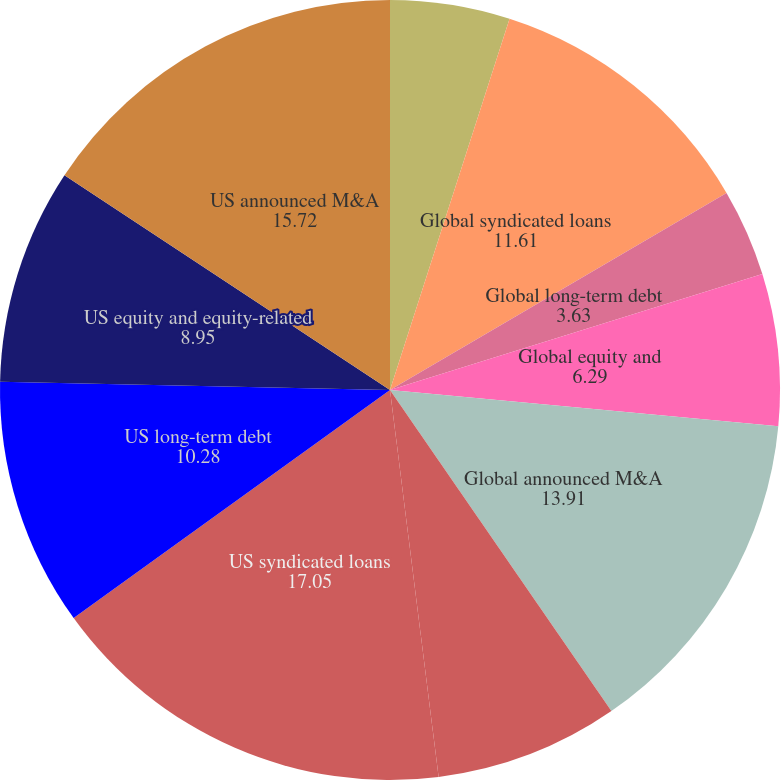Convert chart. <chart><loc_0><loc_0><loc_500><loc_500><pie_chart><fcel>Global debt equity and<fcel>Global syndicated loans<fcel>Global long-term debt<fcel>Global equity and<fcel>Global announced M&A<fcel>US debt equity and<fcel>US syndicated loans<fcel>US long-term debt<fcel>US equity and equity-related<fcel>US announced M&A<nl><fcel>4.96%<fcel>11.61%<fcel>3.63%<fcel>6.29%<fcel>13.91%<fcel>7.62%<fcel>17.05%<fcel>10.28%<fcel>8.95%<fcel>15.72%<nl></chart> 